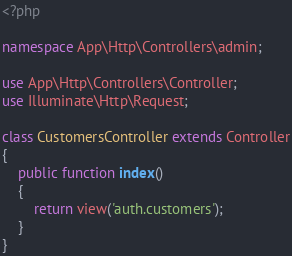Convert code to text. <code><loc_0><loc_0><loc_500><loc_500><_PHP_><?php

namespace App\Http\Controllers\admin;

use App\Http\Controllers\Controller;
use Illuminate\Http\Request;

class CustomersController extends Controller
{
    public function index()
	{
		return view('auth.customers');
	}
}
</code> 